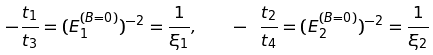Convert formula to latex. <formula><loc_0><loc_0><loc_500><loc_500>- { \frac { t _ { 1 } } { t _ { 3 } } } = ( E _ { 1 } ^ { ( B = 0 ) } ) ^ { - 2 } = { \frac { 1 } { \xi _ { 1 } } } , \quad - { \ \frac { t _ { 2 } } { t _ { 4 } } } = ( E _ { 2 } ^ { ( B = 0 ) } ) ^ { - 2 } = { \frac { 1 } { \xi _ { 2 } } }</formula> 